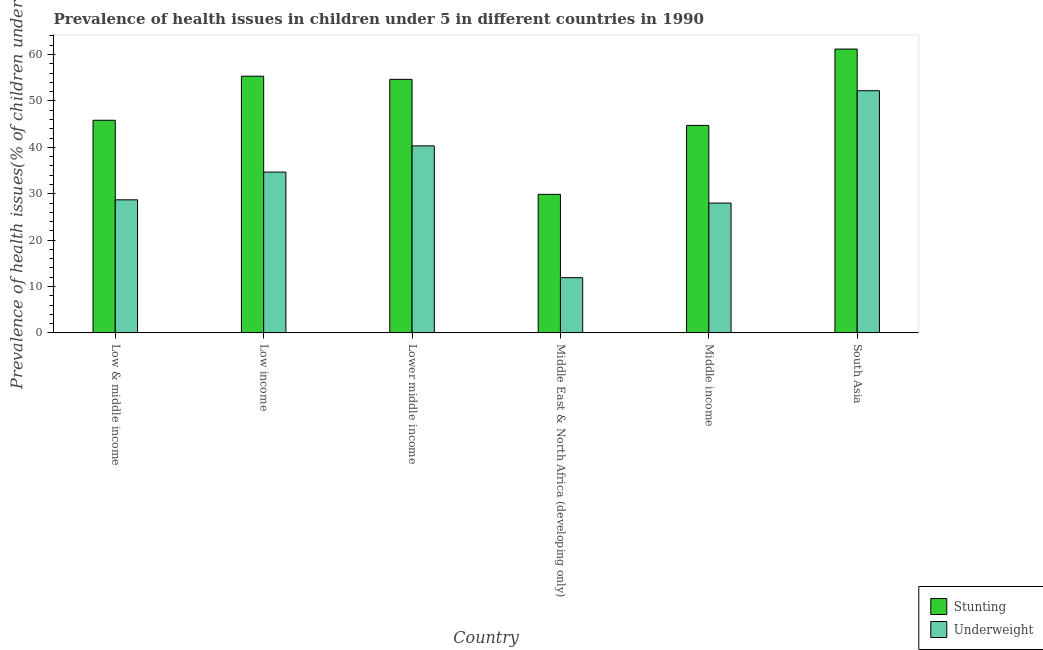How many groups of bars are there?
Offer a very short reply. 6. How many bars are there on the 5th tick from the left?
Offer a terse response. 2. What is the label of the 3rd group of bars from the left?
Offer a terse response. Lower middle income. What is the percentage of underweight children in Middle income?
Give a very brief answer. 27.99. Across all countries, what is the maximum percentage of stunted children?
Keep it short and to the point. 61.17. Across all countries, what is the minimum percentage of underweight children?
Your answer should be very brief. 11.91. In which country was the percentage of underweight children minimum?
Ensure brevity in your answer.  Middle East & North Africa (developing only). What is the total percentage of stunted children in the graph?
Keep it short and to the point. 291.56. What is the difference between the percentage of underweight children in Low income and that in Middle income?
Give a very brief answer. 6.67. What is the difference between the percentage of stunted children in Middle income and the percentage of underweight children in South Asia?
Give a very brief answer. -7.48. What is the average percentage of stunted children per country?
Your response must be concise. 48.59. What is the difference between the percentage of underweight children and percentage of stunted children in Low income?
Keep it short and to the point. -20.66. What is the ratio of the percentage of underweight children in Low income to that in Middle East & North Africa (developing only)?
Your answer should be compact. 2.91. Is the difference between the percentage of stunted children in Low & middle income and Low income greater than the difference between the percentage of underweight children in Low & middle income and Low income?
Provide a succinct answer. No. What is the difference between the highest and the second highest percentage of underweight children?
Give a very brief answer. 11.88. What is the difference between the highest and the lowest percentage of stunted children?
Your answer should be compact. 31.31. What does the 1st bar from the left in Lower middle income represents?
Keep it short and to the point. Stunting. What does the 2nd bar from the right in Middle income represents?
Offer a very short reply. Stunting. How many bars are there?
Make the answer very short. 12. Does the graph contain any zero values?
Ensure brevity in your answer.  No. Does the graph contain grids?
Provide a short and direct response. No. Where does the legend appear in the graph?
Make the answer very short. Bottom right. How are the legend labels stacked?
Make the answer very short. Vertical. What is the title of the graph?
Provide a short and direct response. Prevalence of health issues in children under 5 in different countries in 1990. What is the label or title of the X-axis?
Offer a very short reply. Country. What is the label or title of the Y-axis?
Provide a succinct answer. Prevalence of health issues(% of children under 5). What is the Prevalence of health issues(% of children under 5) in Stunting in Low & middle income?
Offer a terse response. 45.83. What is the Prevalence of health issues(% of children under 5) in Underweight in Low & middle income?
Your answer should be very brief. 28.68. What is the Prevalence of health issues(% of children under 5) of Stunting in Low income?
Make the answer very short. 55.33. What is the Prevalence of health issues(% of children under 5) of Underweight in Low income?
Make the answer very short. 34.66. What is the Prevalence of health issues(% of children under 5) of Stunting in Lower middle income?
Ensure brevity in your answer.  54.65. What is the Prevalence of health issues(% of children under 5) of Underweight in Lower middle income?
Offer a terse response. 40.32. What is the Prevalence of health issues(% of children under 5) in Stunting in Middle East & North Africa (developing only)?
Give a very brief answer. 29.86. What is the Prevalence of health issues(% of children under 5) in Underweight in Middle East & North Africa (developing only)?
Make the answer very short. 11.91. What is the Prevalence of health issues(% of children under 5) in Stunting in Middle income?
Your answer should be compact. 44.72. What is the Prevalence of health issues(% of children under 5) in Underweight in Middle income?
Offer a very short reply. 27.99. What is the Prevalence of health issues(% of children under 5) in Stunting in South Asia?
Give a very brief answer. 61.17. What is the Prevalence of health issues(% of children under 5) in Underweight in South Asia?
Your answer should be very brief. 52.2. Across all countries, what is the maximum Prevalence of health issues(% of children under 5) in Stunting?
Provide a succinct answer. 61.17. Across all countries, what is the maximum Prevalence of health issues(% of children under 5) of Underweight?
Keep it short and to the point. 52.2. Across all countries, what is the minimum Prevalence of health issues(% of children under 5) in Stunting?
Make the answer very short. 29.86. Across all countries, what is the minimum Prevalence of health issues(% of children under 5) of Underweight?
Your response must be concise. 11.91. What is the total Prevalence of health issues(% of children under 5) of Stunting in the graph?
Keep it short and to the point. 291.56. What is the total Prevalence of health issues(% of children under 5) of Underweight in the graph?
Offer a very short reply. 195.76. What is the difference between the Prevalence of health issues(% of children under 5) of Stunting in Low & middle income and that in Low income?
Offer a very short reply. -9.49. What is the difference between the Prevalence of health issues(% of children under 5) of Underweight in Low & middle income and that in Low income?
Provide a short and direct response. -5.98. What is the difference between the Prevalence of health issues(% of children under 5) in Stunting in Low & middle income and that in Lower middle income?
Your response must be concise. -8.82. What is the difference between the Prevalence of health issues(% of children under 5) in Underweight in Low & middle income and that in Lower middle income?
Ensure brevity in your answer.  -11.63. What is the difference between the Prevalence of health issues(% of children under 5) of Stunting in Low & middle income and that in Middle East & North Africa (developing only)?
Provide a short and direct response. 15.97. What is the difference between the Prevalence of health issues(% of children under 5) in Underweight in Low & middle income and that in Middle East & North Africa (developing only)?
Provide a short and direct response. 16.78. What is the difference between the Prevalence of health issues(% of children under 5) of Stunting in Low & middle income and that in Middle income?
Your answer should be compact. 1.11. What is the difference between the Prevalence of health issues(% of children under 5) in Underweight in Low & middle income and that in Middle income?
Offer a very short reply. 0.7. What is the difference between the Prevalence of health issues(% of children under 5) in Stunting in Low & middle income and that in South Asia?
Your response must be concise. -15.34. What is the difference between the Prevalence of health issues(% of children under 5) in Underweight in Low & middle income and that in South Asia?
Keep it short and to the point. -23.51. What is the difference between the Prevalence of health issues(% of children under 5) of Stunting in Low income and that in Lower middle income?
Your answer should be compact. 0.68. What is the difference between the Prevalence of health issues(% of children under 5) of Underweight in Low income and that in Lower middle income?
Provide a succinct answer. -5.66. What is the difference between the Prevalence of health issues(% of children under 5) in Stunting in Low income and that in Middle East & North Africa (developing only)?
Your answer should be compact. 25.46. What is the difference between the Prevalence of health issues(% of children under 5) of Underweight in Low income and that in Middle East & North Africa (developing only)?
Keep it short and to the point. 22.75. What is the difference between the Prevalence of health issues(% of children under 5) in Stunting in Low income and that in Middle income?
Provide a short and direct response. 10.6. What is the difference between the Prevalence of health issues(% of children under 5) of Underweight in Low income and that in Middle income?
Your response must be concise. 6.67. What is the difference between the Prevalence of health issues(% of children under 5) in Stunting in Low income and that in South Asia?
Provide a short and direct response. -5.85. What is the difference between the Prevalence of health issues(% of children under 5) in Underweight in Low income and that in South Asia?
Your response must be concise. -17.54. What is the difference between the Prevalence of health issues(% of children under 5) in Stunting in Lower middle income and that in Middle East & North Africa (developing only)?
Make the answer very short. 24.79. What is the difference between the Prevalence of health issues(% of children under 5) in Underweight in Lower middle income and that in Middle East & North Africa (developing only)?
Keep it short and to the point. 28.41. What is the difference between the Prevalence of health issues(% of children under 5) in Stunting in Lower middle income and that in Middle income?
Provide a short and direct response. 9.92. What is the difference between the Prevalence of health issues(% of children under 5) of Underweight in Lower middle income and that in Middle income?
Offer a very short reply. 12.33. What is the difference between the Prevalence of health issues(% of children under 5) in Stunting in Lower middle income and that in South Asia?
Give a very brief answer. -6.52. What is the difference between the Prevalence of health issues(% of children under 5) of Underweight in Lower middle income and that in South Asia?
Your answer should be very brief. -11.88. What is the difference between the Prevalence of health issues(% of children under 5) in Stunting in Middle East & North Africa (developing only) and that in Middle income?
Keep it short and to the point. -14.86. What is the difference between the Prevalence of health issues(% of children under 5) of Underweight in Middle East & North Africa (developing only) and that in Middle income?
Make the answer very short. -16.08. What is the difference between the Prevalence of health issues(% of children under 5) of Stunting in Middle East & North Africa (developing only) and that in South Asia?
Offer a very short reply. -31.31. What is the difference between the Prevalence of health issues(% of children under 5) of Underweight in Middle East & North Africa (developing only) and that in South Asia?
Provide a short and direct response. -40.29. What is the difference between the Prevalence of health issues(% of children under 5) of Stunting in Middle income and that in South Asia?
Your answer should be compact. -16.45. What is the difference between the Prevalence of health issues(% of children under 5) in Underweight in Middle income and that in South Asia?
Give a very brief answer. -24.21. What is the difference between the Prevalence of health issues(% of children under 5) in Stunting in Low & middle income and the Prevalence of health issues(% of children under 5) in Underweight in Low income?
Your answer should be very brief. 11.17. What is the difference between the Prevalence of health issues(% of children under 5) in Stunting in Low & middle income and the Prevalence of health issues(% of children under 5) in Underweight in Lower middle income?
Your response must be concise. 5.51. What is the difference between the Prevalence of health issues(% of children under 5) in Stunting in Low & middle income and the Prevalence of health issues(% of children under 5) in Underweight in Middle East & North Africa (developing only)?
Offer a terse response. 33.92. What is the difference between the Prevalence of health issues(% of children under 5) of Stunting in Low & middle income and the Prevalence of health issues(% of children under 5) of Underweight in Middle income?
Offer a very short reply. 17.84. What is the difference between the Prevalence of health issues(% of children under 5) in Stunting in Low & middle income and the Prevalence of health issues(% of children under 5) in Underweight in South Asia?
Provide a succinct answer. -6.37. What is the difference between the Prevalence of health issues(% of children under 5) in Stunting in Low income and the Prevalence of health issues(% of children under 5) in Underweight in Lower middle income?
Offer a terse response. 15.01. What is the difference between the Prevalence of health issues(% of children under 5) in Stunting in Low income and the Prevalence of health issues(% of children under 5) in Underweight in Middle East & North Africa (developing only)?
Make the answer very short. 43.42. What is the difference between the Prevalence of health issues(% of children under 5) of Stunting in Low income and the Prevalence of health issues(% of children under 5) of Underweight in Middle income?
Offer a very short reply. 27.34. What is the difference between the Prevalence of health issues(% of children under 5) of Stunting in Low income and the Prevalence of health issues(% of children under 5) of Underweight in South Asia?
Provide a succinct answer. 3.13. What is the difference between the Prevalence of health issues(% of children under 5) of Stunting in Lower middle income and the Prevalence of health issues(% of children under 5) of Underweight in Middle East & North Africa (developing only)?
Your response must be concise. 42.74. What is the difference between the Prevalence of health issues(% of children under 5) of Stunting in Lower middle income and the Prevalence of health issues(% of children under 5) of Underweight in Middle income?
Your answer should be very brief. 26.66. What is the difference between the Prevalence of health issues(% of children under 5) of Stunting in Lower middle income and the Prevalence of health issues(% of children under 5) of Underweight in South Asia?
Give a very brief answer. 2.45. What is the difference between the Prevalence of health issues(% of children under 5) of Stunting in Middle East & North Africa (developing only) and the Prevalence of health issues(% of children under 5) of Underweight in Middle income?
Offer a terse response. 1.87. What is the difference between the Prevalence of health issues(% of children under 5) in Stunting in Middle East & North Africa (developing only) and the Prevalence of health issues(% of children under 5) in Underweight in South Asia?
Provide a short and direct response. -22.34. What is the difference between the Prevalence of health issues(% of children under 5) of Stunting in Middle income and the Prevalence of health issues(% of children under 5) of Underweight in South Asia?
Ensure brevity in your answer.  -7.48. What is the average Prevalence of health issues(% of children under 5) in Stunting per country?
Offer a terse response. 48.59. What is the average Prevalence of health issues(% of children under 5) in Underweight per country?
Your response must be concise. 32.63. What is the difference between the Prevalence of health issues(% of children under 5) of Stunting and Prevalence of health issues(% of children under 5) of Underweight in Low & middle income?
Offer a terse response. 17.15. What is the difference between the Prevalence of health issues(% of children under 5) in Stunting and Prevalence of health issues(% of children under 5) in Underweight in Low income?
Your answer should be compact. 20.66. What is the difference between the Prevalence of health issues(% of children under 5) in Stunting and Prevalence of health issues(% of children under 5) in Underweight in Lower middle income?
Offer a very short reply. 14.33. What is the difference between the Prevalence of health issues(% of children under 5) of Stunting and Prevalence of health issues(% of children under 5) of Underweight in Middle East & North Africa (developing only)?
Provide a succinct answer. 17.95. What is the difference between the Prevalence of health issues(% of children under 5) of Stunting and Prevalence of health issues(% of children under 5) of Underweight in Middle income?
Make the answer very short. 16.74. What is the difference between the Prevalence of health issues(% of children under 5) of Stunting and Prevalence of health issues(% of children under 5) of Underweight in South Asia?
Provide a short and direct response. 8.97. What is the ratio of the Prevalence of health issues(% of children under 5) in Stunting in Low & middle income to that in Low income?
Make the answer very short. 0.83. What is the ratio of the Prevalence of health issues(% of children under 5) in Underweight in Low & middle income to that in Low income?
Offer a very short reply. 0.83. What is the ratio of the Prevalence of health issues(% of children under 5) in Stunting in Low & middle income to that in Lower middle income?
Your answer should be compact. 0.84. What is the ratio of the Prevalence of health issues(% of children under 5) in Underweight in Low & middle income to that in Lower middle income?
Keep it short and to the point. 0.71. What is the ratio of the Prevalence of health issues(% of children under 5) in Stunting in Low & middle income to that in Middle East & North Africa (developing only)?
Provide a succinct answer. 1.53. What is the ratio of the Prevalence of health issues(% of children under 5) in Underweight in Low & middle income to that in Middle East & North Africa (developing only)?
Keep it short and to the point. 2.41. What is the ratio of the Prevalence of health issues(% of children under 5) of Stunting in Low & middle income to that in Middle income?
Provide a short and direct response. 1.02. What is the ratio of the Prevalence of health issues(% of children under 5) of Underweight in Low & middle income to that in Middle income?
Your answer should be compact. 1.02. What is the ratio of the Prevalence of health issues(% of children under 5) of Stunting in Low & middle income to that in South Asia?
Provide a short and direct response. 0.75. What is the ratio of the Prevalence of health issues(% of children under 5) in Underweight in Low & middle income to that in South Asia?
Ensure brevity in your answer.  0.55. What is the ratio of the Prevalence of health issues(% of children under 5) of Stunting in Low income to that in Lower middle income?
Give a very brief answer. 1.01. What is the ratio of the Prevalence of health issues(% of children under 5) in Underweight in Low income to that in Lower middle income?
Your response must be concise. 0.86. What is the ratio of the Prevalence of health issues(% of children under 5) of Stunting in Low income to that in Middle East & North Africa (developing only)?
Give a very brief answer. 1.85. What is the ratio of the Prevalence of health issues(% of children under 5) in Underweight in Low income to that in Middle East & North Africa (developing only)?
Your response must be concise. 2.91. What is the ratio of the Prevalence of health issues(% of children under 5) in Stunting in Low income to that in Middle income?
Your answer should be very brief. 1.24. What is the ratio of the Prevalence of health issues(% of children under 5) of Underweight in Low income to that in Middle income?
Your answer should be compact. 1.24. What is the ratio of the Prevalence of health issues(% of children under 5) of Stunting in Low income to that in South Asia?
Ensure brevity in your answer.  0.9. What is the ratio of the Prevalence of health issues(% of children under 5) in Underweight in Low income to that in South Asia?
Your response must be concise. 0.66. What is the ratio of the Prevalence of health issues(% of children under 5) in Stunting in Lower middle income to that in Middle East & North Africa (developing only)?
Keep it short and to the point. 1.83. What is the ratio of the Prevalence of health issues(% of children under 5) in Underweight in Lower middle income to that in Middle East & North Africa (developing only)?
Your response must be concise. 3.39. What is the ratio of the Prevalence of health issues(% of children under 5) in Stunting in Lower middle income to that in Middle income?
Ensure brevity in your answer.  1.22. What is the ratio of the Prevalence of health issues(% of children under 5) in Underweight in Lower middle income to that in Middle income?
Keep it short and to the point. 1.44. What is the ratio of the Prevalence of health issues(% of children under 5) in Stunting in Lower middle income to that in South Asia?
Give a very brief answer. 0.89. What is the ratio of the Prevalence of health issues(% of children under 5) in Underweight in Lower middle income to that in South Asia?
Make the answer very short. 0.77. What is the ratio of the Prevalence of health issues(% of children under 5) in Stunting in Middle East & North Africa (developing only) to that in Middle income?
Make the answer very short. 0.67. What is the ratio of the Prevalence of health issues(% of children under 5) of Underweight in Middle East & North Africa (developing only) to that in Middle income?
Offer a terse response. 0.43. What is the ratio of the Prevalence of health issues(% of children under 5) in Stunting in Middle East & North Africa (developing only) to that in South Asia?
Offer a very short reply. 0.49. What is the ratio of the Prevalence of health issues(% of children under 5) in Underweight in Middle East & North Africa (developing only) to that in South Asia?
Give a very brief answer. 0.23. What is the ratio of the Prevalence of health issues(% of children under 5) in Stunting in Middle income to that in South Asia?
Your response must be concise. 0.73. What is the ratio of the Prevalence of health issues(% of children under 5) in Underweight in Middle income to that in South Asia?
Provide a short and direct response. 0.54. What is the difference between the highest and the second highest Prevalence of health issues(% of children under 5) in Stunting?
Keep it short and to the point. 5.85. What is the difference between the highest and the second highest Prevalence of health issues(% of children under 5) of Underweight?
Offer a very short reply. 11.88. What is the difference between the highest and the lowest Prevalence of health issues(% of children under 5) of Stunting?
Your answer should be very brief. 31.31. What is the difference between the highest and the lowest Prevalence of health issues(% of children under 5) in Underweight?
Offer a terse response. 40.29. 